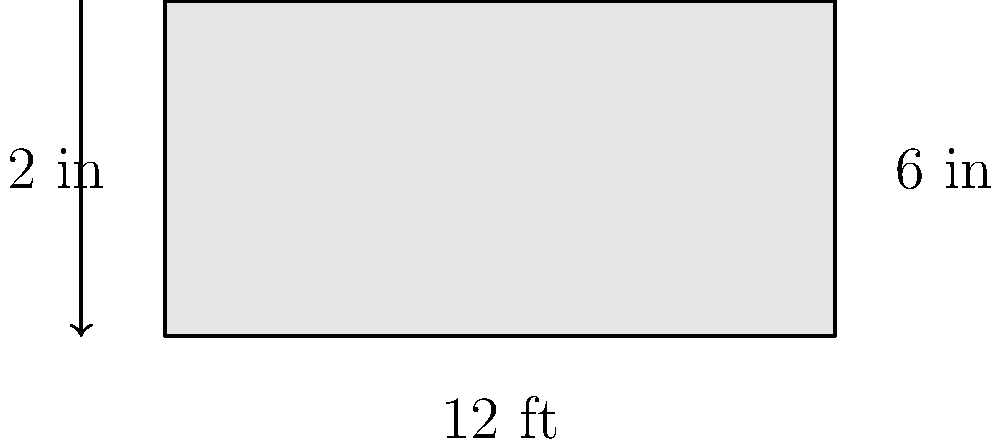As a wood retailer in Seattle, you need to calculate the board feet of a lumber piece. The board measures 12 feet in length, 6 inches in width, and 2 inches in thickness. How many board feet of lumber does this piece contain? To calculate board feet, we use the formula:

$$ \text{Board Feet} = \frac{\text{Length (ft)} \times \text{Width (in)} \times \text{Thickness (in)}}{12} $$

Let's plug in the values:

1. Length = 12 feet
2. Width = 6 inches
3. Thickness = 2 inches

$$ \text{Board Feet} = \frac{12 \text{ ft} \times 6 \text{ in} \times 2 \text{ in}}{12} $$

Simplify:
$$ \text{Board Feet} = \frac{144}{12} = 12 $$

Therefore, the lumber piece contains 12 board feet.
Answer: 12 board feet 